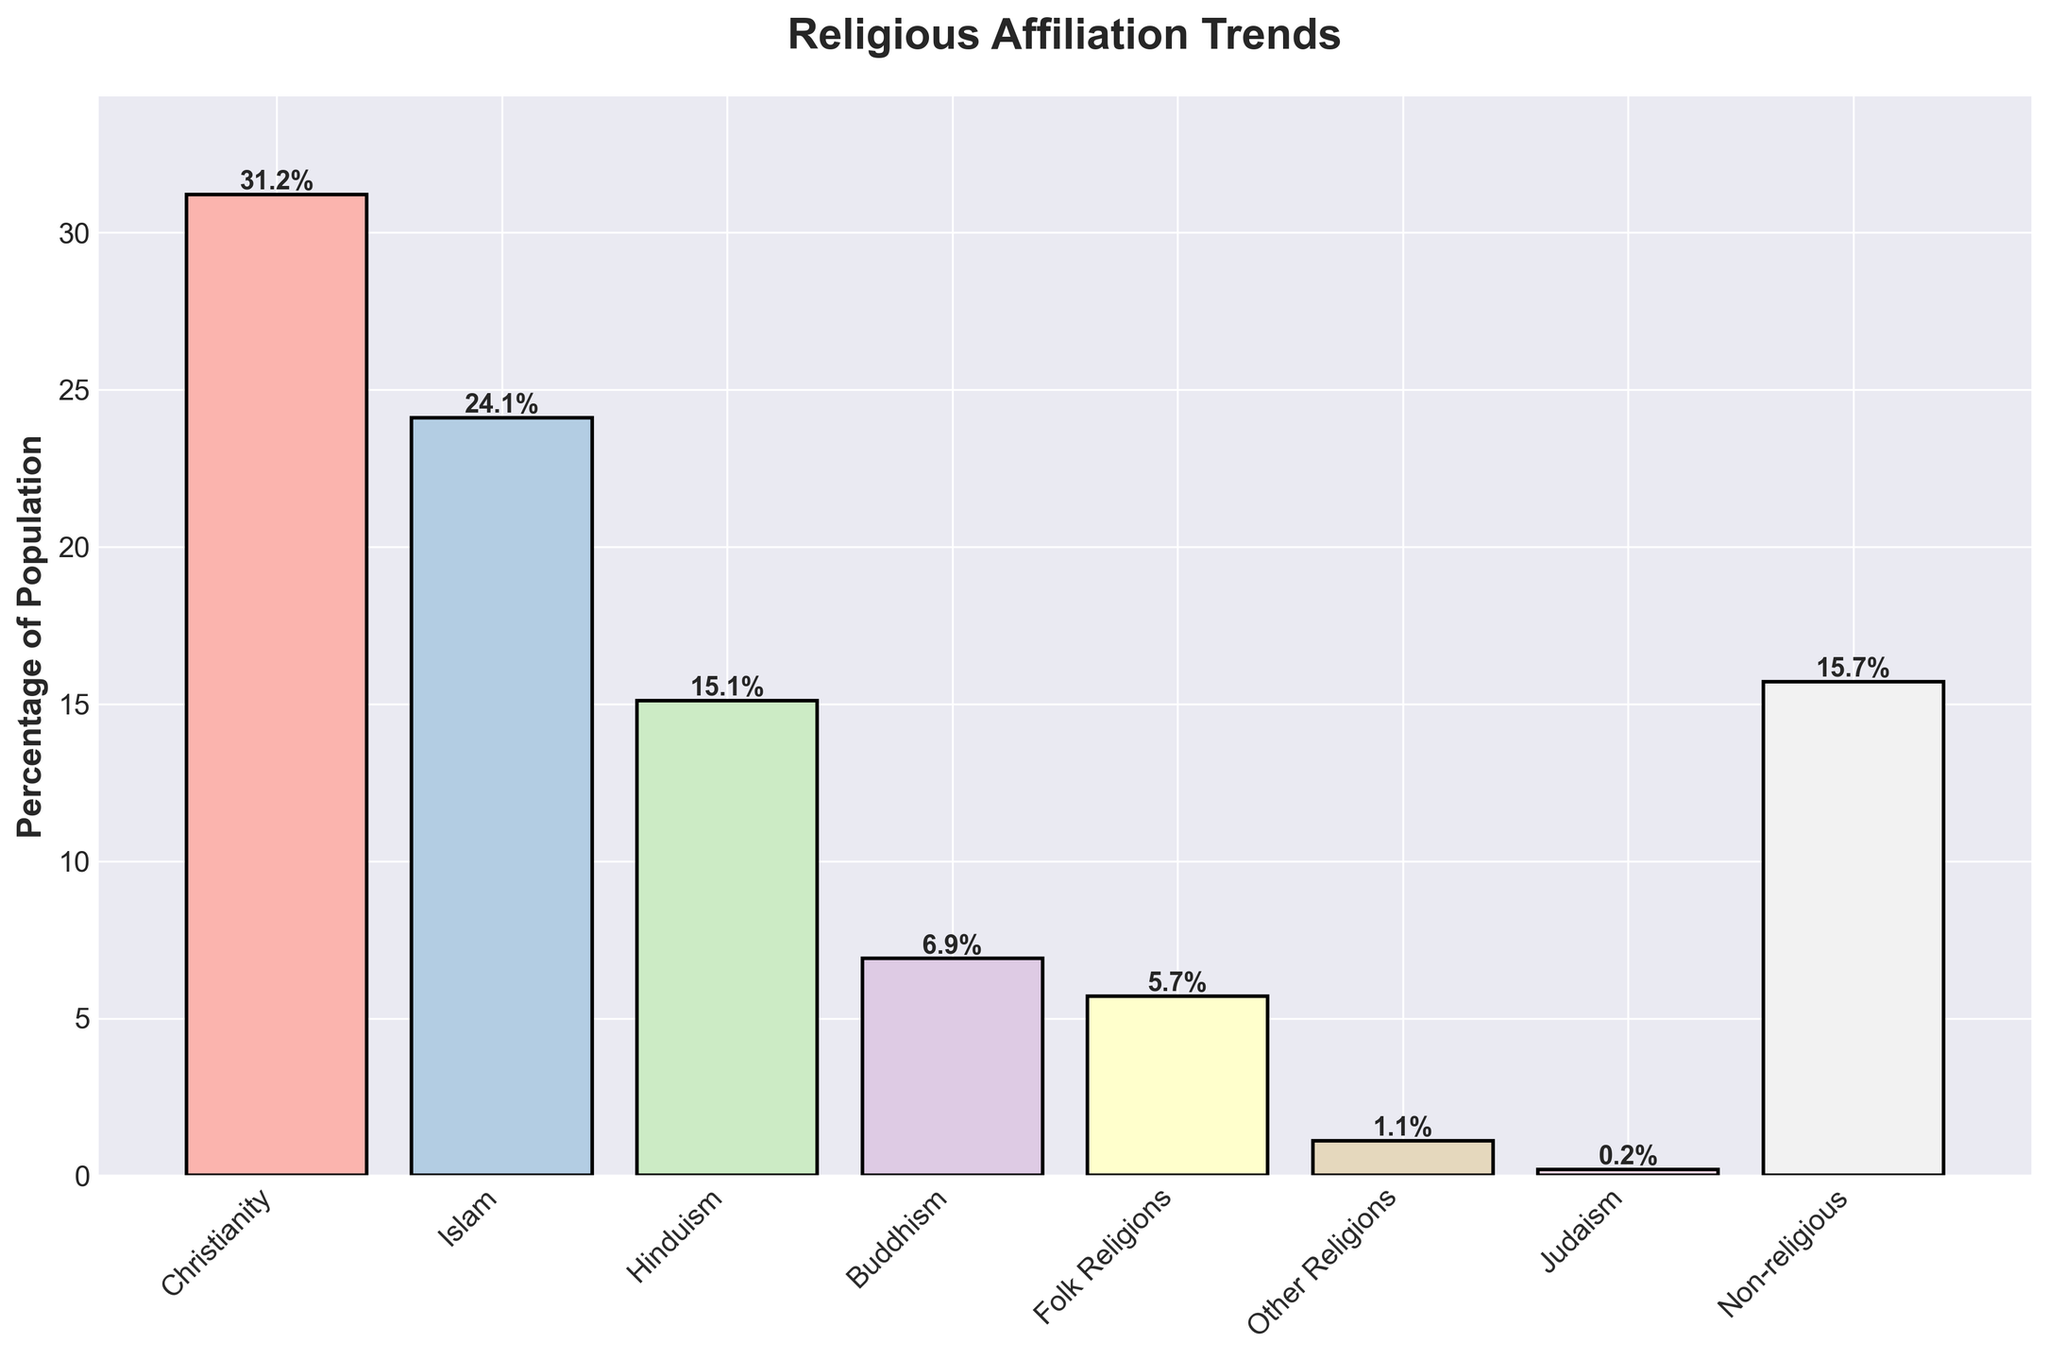Which religion has the highest percentage of followers according to the chart? According to the chart, Christianity has the highest percentage of followers. The height of the bar representing Christianity is the tallest, reaching 31.2%.
Answer: Christianity Among Christianity, Islam, and Hinduism, which religion has the smallest percentage of followers? To find the smallest percentage among Christianity, Islam, and Hinduism, compare their bars. Christianity has 31.2%, Islam has 24.1%, and Hinduism has 15.1%. Hinduism is the smallest.
Answer: Hinduism What is the total percentage of the population that identifies with either Buddhism, Folk Religions, or Other Religions? Add the percentages of Buddhism (6.9%), Folk Religions (5.7%), and Other Religions (1.1%). The sum is 6.9 + 5.7 + 1.1 = 13.7%.
Answer: 13.7% Compare the percentage of non-religious people with the percentage of people identifying as Hinduism. Which group has a higher percentage? Compare the bar heights of non-religious (15.7%) and Hinduism (15.1%). Non-religious has a slightly higher percentage.
Answer: Non-religious What is the difference in percentage between people identifying with Folk Religions and Other Religions? Subtract the percentage of Other Religions (1.1%) from Folk Religions (5.7%). The difference is 5.7 - 1.1 = 4.6%.
Answer: 4.6% Is the percentage of non-religious individuals higher than the percentage of Buddhist followers? Compare the non-religious percentage (15.7%) with Buddhist followers (6.9%). The non-religious percentage is higher.
Answer: Yes What is the combined percentage of the population identifying with Christianity and Islam? Add the percentages of Christianity (31.2%) and Islam (24.1%). The combined percentage is 31.2 + 24.1 = 55.3%.
Answer: 55.3% How many religions have a population percentage below 5%? Identify all religions with bars below 5%. Folk Religions (5.7%) is above but Other Religions (1.1%), Judaism (0.2%) are both below. Thus, there are two.
Answer: 2 What is the average percentage of the population identifying with the listed religions excluding non-religious? Sum the listed religions' percentages (exclude non-religious): 31.2 (Christianity) + 24.1 (Islam) + 15.1 (Hinduism) + 6.9 (Buddhism) + 5.7 (Folk Religions) + 1.1 (Other Religions) + 0.2 (Judaism) = 84.3. There are 7 religions listed, so the average is 84.3 / 7 = 12.04%.
Answer: 12.04% 